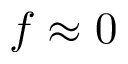Convert formula to latex. <formula><loc_0><loc_0><loc_500><loc_500>f \approx 0</formula> 